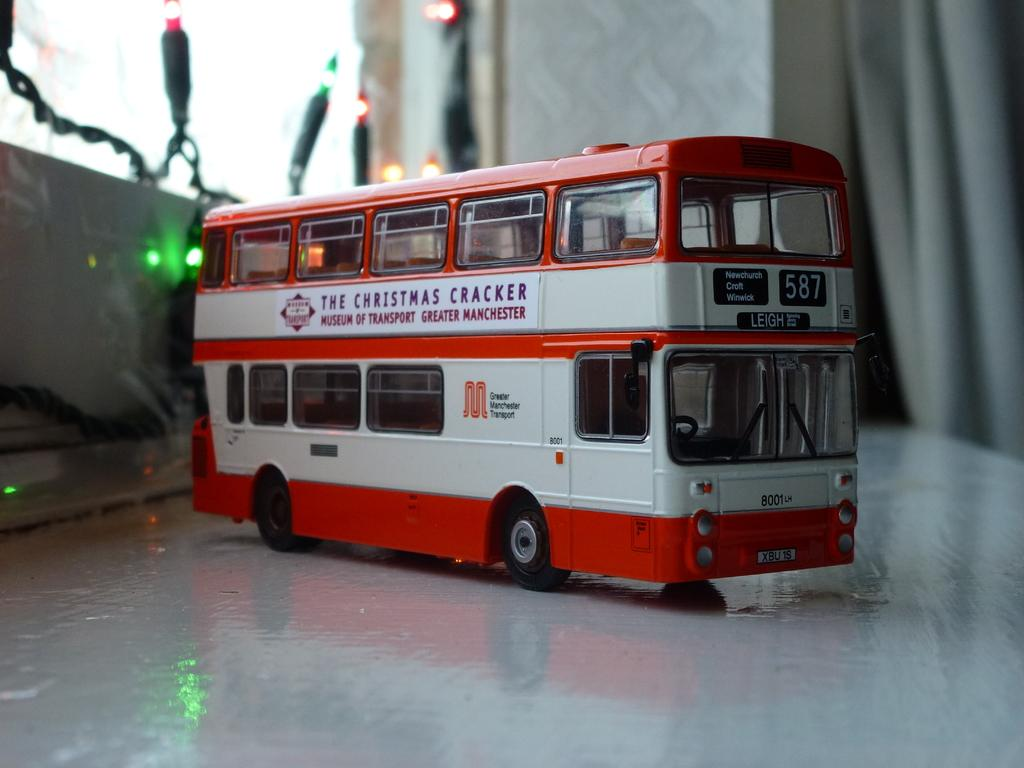What is the main subject in the middle of the image? There is a bus in the middle of the image. What type of lighting is present in the image? Decor lights are present in the image. What type of covering can be seen in the image? There is a curtain in the image. What type of structure is visible in the image? A wall is visible in the image. What surface is visible in the image? There is a floor in the image. How many pickles are on the bus in the image? There are no pickles present on the bus or in the image. 